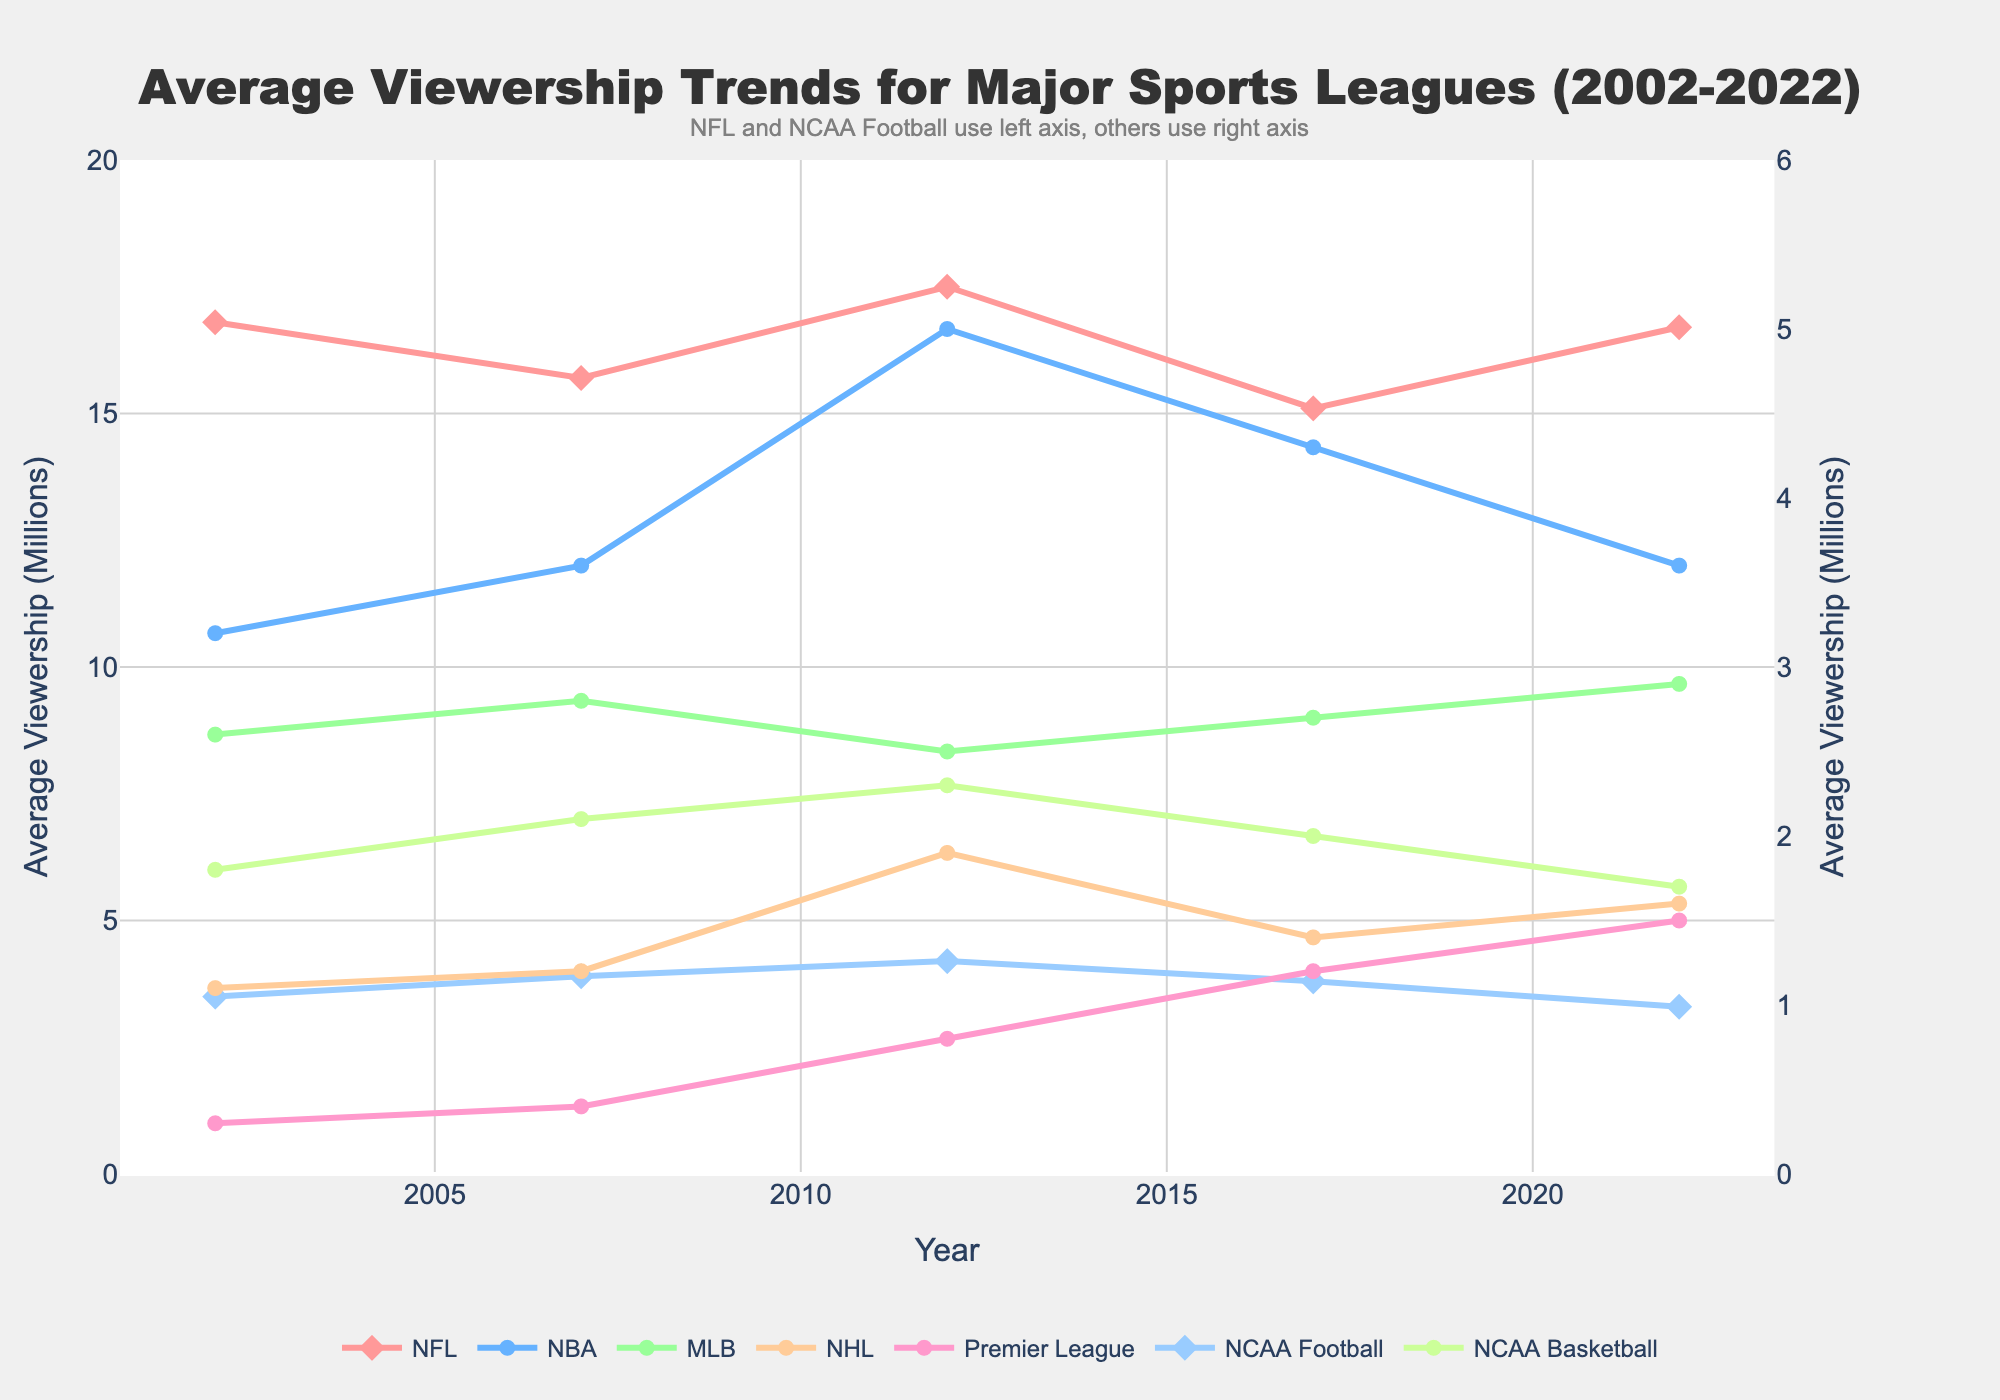What league had the highest average viewership in 2022? By examining the peaks in 2022 data points, the highest point belongs to the NFL at around 16.7 million viewers.
Answer: NFL Between 2012 and 2017, which league saw the largest drop in average viewership? By comparing the 2012 and 2017 data points for each league, the NBA has dropped from around 5.0 million to 4.3 million viewers, which is the largest decrease.
Answer: NBA In 2022, how does the Premier League's average viewership compare to that of the NHL? In 2022, the Premier League has approximately 1.5 million viewers, and the NHL has around 1.6 million viewers. The NHL has slightly higher viewership.
Answer: NHL Which league experienced consistent growth in viewership from 2002 to 2022? Looking across the years for each league, there's consistent growth in the Premier League’s viewership from 0.3 million in 2002 to 1.5 million in 2022.
Answer: Premier League What is the total combined viewership for NFL and NCAA Football in 2012? Adding the viewership numbers for NFL (17.5 million) and NCAA Football (4.2 million) in 2012 gives a total of 21.7 million viewers.
Answer: 21.7 million In which year did the MLB achieve its peak viewership and what was the value? MLB’s highest data point is in 2022 with 2.9 million viewers.
Answer: 2022, 2.9 million Calculate the average viewership of NBA from 2002 to 2022. Summing the NBA viewership data (3.2, 3.6, 5.0, 4.3, 3.6) and dividing by 5 gives (3.2 + 3.6 + 5.0 + 4.3 + 3.6) / 5 = 3.94 million.
Answer: 3.94 million Which two leagues used the left axis in the plot? From the annotation, NFL and NCAA Football are noted to use the left y-axis.
Answer: NFL, NCAA Football Which league showed the maximum increase in viewership between 2002 and 2022? Subtracting 2002 viewership from 2022 viewership for each league, the NFL increased from 16.8 to 16.7 (slight change). The largest increase is for the Premier League from 0.3 to 1.5, an increase of 1.2 million.
Answer: Premier League How many leagues had a viewership below 2 million in 2002? By checking the 2002 viewership values, MLB, NHL, Premier League, and NCAA Basketball all had viewership numbers below 2 million. That makes 4 leagues.
Answer: 4 